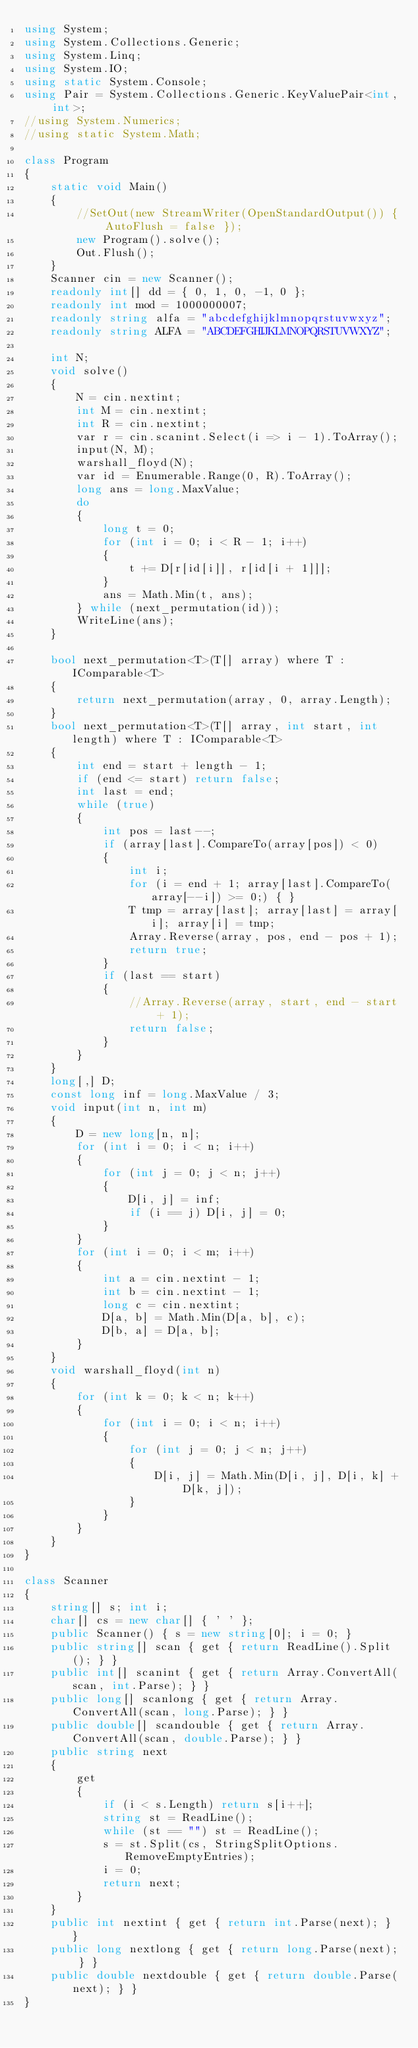Convert code to text. <code><loc_0><loc_0><loc_500><loc_500><_C#_>using System;
using System.Collections.Generic;
using System.Linq;
using System.IO;
using static System.Console;
using Pair = System.Collections.Generic.KeyValuePair<int, int>;
//using System.Numerics;
//using static System.Math;

class Program
{
    static void Main()
    {
        //SetOut(new StreamWriter(OpenStandardOutput()) { AutoFlush = false });
        new Program().solve();
        Out.Flush();
    }
    Scanner cin = new Scanner();
    readonly int[] dd = { 0, 1, 0, -1, 0 };
    readonly int mod = 1000000007;
    readonly string alfa = "abcdefghijklmnopqrstuvwxyz";
    readonly string ALFA = "ABCDEFGHIJKLMNOPQRSTUVWXYZ";

    int N;
    void solve()
    {
        N = cin.nextint;
        int M = cin.nextint;
        int R = cin.nextint;
        var r = cin.scanint.Select(i => i - 1).ToArray();
        input(N, M);
        warshall_floyd(N);
        var id = Enumerable.Range(0, R).ToArray();
        long ans = long.MaxValue;
        do
        {
            long t = 0;
            for (int i = 0; i < R - 1; i++)
            {
                t += D[r[id[i]], r[id[i + 1]]];
            }
            ans = Math.Min(t, ans);
        } while (next_permutation(id));
        WriteLine(ans);
    }

    bool next_permutation<T>(T[] array) where T : IComparable<T>
    {
        return next_permutation(array, 0, array.Length);
    }
    bool next_permutation<T>(T[] array, int start, int length) where T : IComparable<T>
    {
        int end = start + length - 1;
        if (end <= start) return false;
        int last = end;
        while (true)
        {
            int pos = last--;
            if (array[last].CompareTo(array[pos]) < 0)
            {
                int i;
                for (i = end + 1; array[last].CompareTo(array[--i]) >= 0;) { }
                T tmp = array[last]; array[last] = array[i]; array[i] = tmp;
                Array.Reverse(array, pos, end - pos + 1);
                return true;
            }
            if (last == start)
            {
                //Array.Reverse(array, start, end - start + 1);
                return false;
            }
        }
    }
    long[,] D;
    const long inf = long.MaxValue / 3;
    void input(int n, int m)
    {
        D = new long[n, n];
        for (int i = 0; i < n; i++)
        {
            for (int j = 0; j < n; j++)
            {
                D[i, j] = inf;
                if (i == j) D[i, j] = 0;
            }
        }
        for (int i = 0; i < m; i++)
        {
            int a = cin.nextint - 1;
            int b = cin.nextint - 1;
            long c = cin.nextint;
            D[a, b] = Math.Min(D[a, b], c);
            D[b, a] = D[a, b];
        }       
    }
    void warshall_floyd(int n)
    {
        for (int k = 0; k < n; k++)
        {
            for (int i = 0; i < n; i++)
            {
                for (int j = 0; j < n; j++)
                {
                    D[i, j] = Math.Min(D[i, j], D[i, k] + D[k, j]);
                }
            }
        }
    }
}

class Scanner
{
    string[] s; int i;
    char[] cs = new char[] { ' ' };
    public Scanner() { s = new string[0]; i = 0; }
    public string[] scan { get { return ReadLine().Split(); } }
    public int[] scanint { get { return Array.ConvertAll(scan, int.Parse); } }
    public long[] scanlong { get { return Array.ConvertAll(scan, long.Parse); } }
    public double[] scandouble { get { return Array.ConvertAll(scan, double.Parse); } }
    public string next
    {
        get
        {
            if (i < s.Length) return s[i++];
            string st = ReadLine();
            while (st == "") st = ReadLine();
            s = st.Split(cs, StringSplitOptions.RemoveEmptyEntries);
            i = 0;
            return next;
        }
    }
    public int nextint { get { return int.Parse(next); } }
    public long nextlong { get { return long.Parse(next); } }
    public double nextdouble { get { return double.Parse(next); } }
}</code> 